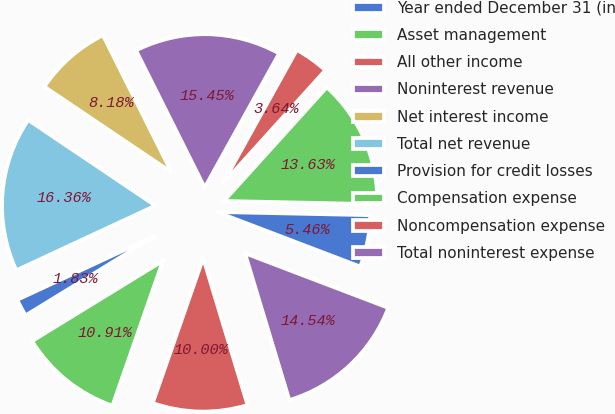<chart> <loc_0><loc_0><loc_500><loc_500><pie_chart><fcel>Year ended December 31 (in<fcel>Asset management<fcel>All other income<fcel>Noninterest revenue<fcel>Net interest income<fcel>Total net revenue<fcel>Provision for credit losses<fcel>Compensation expense<fcel>Noncompensation expense<fcel>Total noninterest expense<nl><fcel>5.46%<fcel>13.63%<fcel>3.64%<fcel>15.45%<fcel>8.18%<fcel>16.36%<fcel>1.83%<fcel>10.91%<fcel>10.0%<fcel>14.54%<nl></chart> 